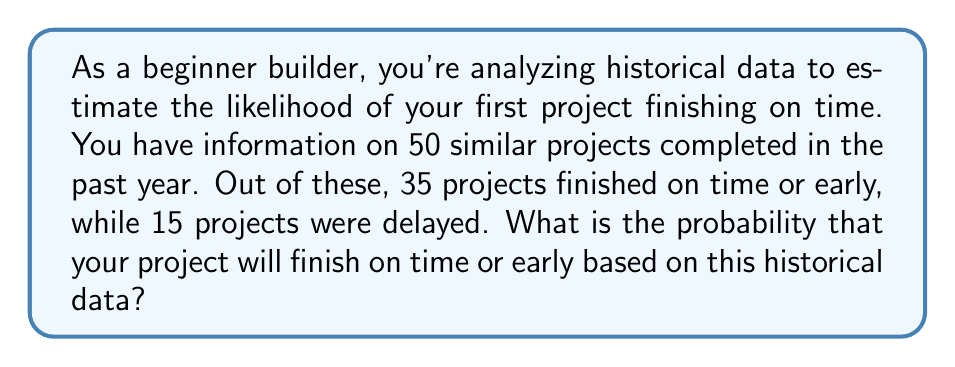What is the answer to this math problem? To solve this problem, we'll use the concept of relative frequency as an estimate of probability. The steps are as follows:

1. Identify the total number of projects in the dataset:
   $n_{total} = 50$

2. Count the number of projects that finished on time or early:
   $n_{on time} = 35$

3. Calculate the probability using the formula:
   $$P(\text{on time}) = \frac{n_{on time}}{n_{total}}$$

4. Substitute the values:
   $$P(\text{on time}) = \frac{35}{50}$$

5. Simplify the fraction:
   $$P(\text{on time}) = \frac{7}{10} = 0.7$$

Therefore, based on the historical data, the probability that your project will finish on time or early is 0.7 or 70%.

It's important to note that this is an estimate based on past performance and assumes that the conditions for your project are similar to those in the historical data. Factors such as project complexity, team experience, and external circumstances can influence the actual outcome.
Answer: The probability that the project will finish on time or early is $0.7$ or $70\%$. 